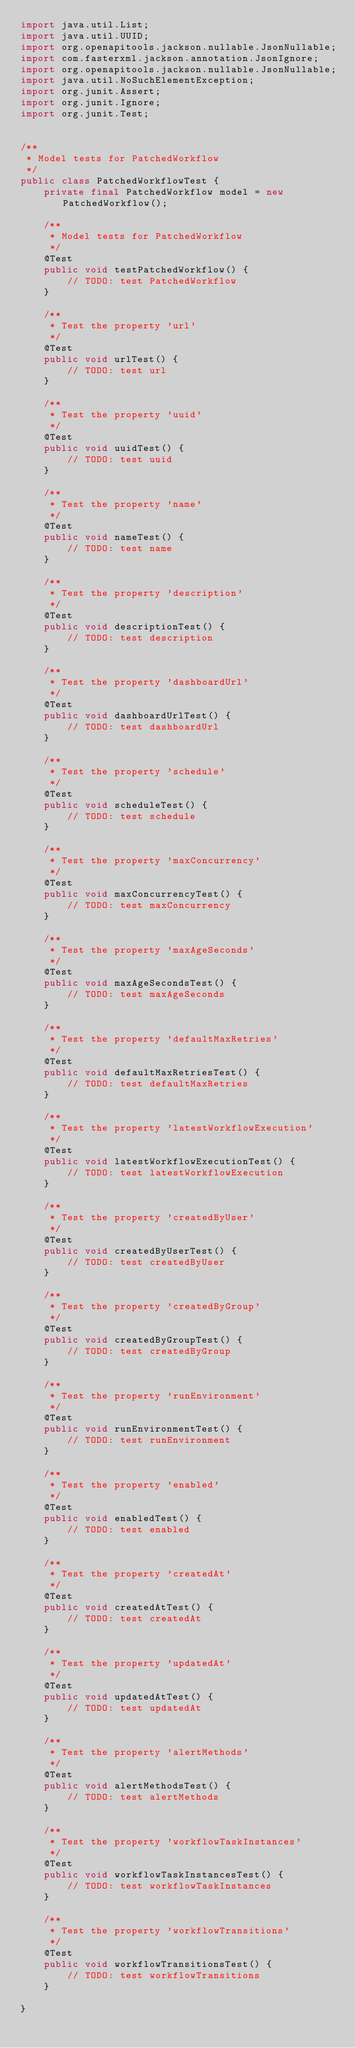<code> <loc_0><loc_0><loc_500><loc_500><_Java_>import java.util.List;
import java.util.UUID;
import org.openapitools.jackson.nullable.JsonNullable;
import com.fasterxml.jackson.annotation.JsonIgnore;
import org.openapitools.jackson.nullable.JsonNullable;
import java.util.NoSuchElementException;
import org.junit.Assert;
import org.junit.Ignore;
import org.junit.Test;


/**
 * Model tests for PatchedWorkflow
 */
public class PatchedWorkflowTest {
    private final PatchedWorkflow model = new PatchedWorkflow();

    /**
     * Model tests for PatchedWorkflow
     */
    @Test
    public void testPatchedWorkflow() {
        // TODO: test PatchedWorkflow
    }

    /**
     * Test the property 'url'
     */
    @Test
    public void urlTest() {
        // TODO: test url
    }

    /**
     * Test the property 'uuid'
     */
    @Test
    public void uuidTest() {
        // TODO: test uuid
    }

    /**
     * Test the property 'name'
     */
    @Test
    public void nameTest() {
        // TODO: test name
    }

    /**
     * Test the property 'description'
     */
    @Test
    public void descriptionTest() {
        // TODO: test description
    }

    /**
     * Test the property 'dashboardUrl'
     */
    @Test
    public void dashboardUrlTest() {
        // TODO: test dashboardUrl
    }

    /**
     * Test the property 'schedule'
     */
    @Test
    public void scheduleTest() {
        // TODO: test schedule
    }

    /**
     * Test the property 'maxConcurrency'
     */
    @Test
    public void maxConcurrencyTest() {
        // TODO: test maxConcurrency
    }

    /**
     * Test the property 'maxAgeSeconds'
     */
    @Test
    public void maxAgeSecondsTest() {
        // TODO: test maxAgeSeconds
    }

    /**
     * Test the property 'defaultMaxRetries'
     */
    @Test
    public void defaultMaxRetriesTest() {
        // TODO: test defaultMaxRetries
    }

    /**
     * Test the property 'latestWorkflowExecution'
     */
    @Test
    public void latestWorkflowExecutionTest() {
        // TODO: test latestWorkflowExecution
    }

    /**
     * Test the property 'createdByUser'
     */
    @Test
    public void createdByUserTest() {
        // TODO: test createdByUser
    }

    /**
     * Test the property 'createdByGroup'
     */
    @Test
    public void createdByGroupTest() {
        // TODO: test createdByGroup
    }

    /**
     * Test the property 'runEnvironment'
     */
    @Test
    public void runEnvironmentTest() {
        // TODO: test runEnvironment
    }

    /**
     * Test the property 'enabled'
     */
    @Test
    public void enabledTest() {
        // TODO: test enabled
    }

    /**
     * Test the property 'createdAt'
     */
    @Test
    public void createdAtTest() {
        // TODO: test createdAt
    }

    /**
     * Test the property 'updatedAt'
     */
    @Test
    public void updatedAtTest() {
        // TODO: test updatedAt
    }

    /**
     * Test the property 'alertMethods'
     */
    @Test
    public void alertMethodsTest() {
        // TODO: test alertMethods
    }

    /**
     * Test the property 'workflowTaskInstances'
     */
    @Test
    public void workflowTaskInstancesTest() {
        // TODO: test workflowTaskInstances
    }

    /**
     * Test the property 'workflowTransitions'
     */
    @Test
    public void workflowTransitionsTest() {
        // TODO: test workflowTransitions
    }

}
</code> 